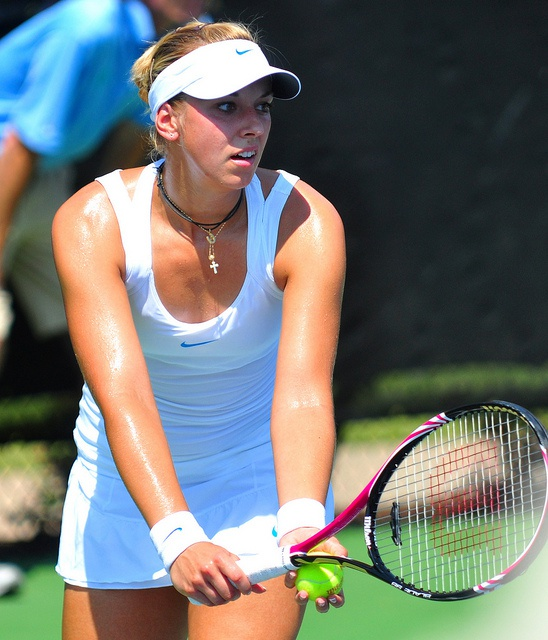Describe the objects in this image and their specific colors. I can see people in black, white, lightblue, salmon, and tan tones, people in black, teal, gray, and lightblue tones, tennis racket in black, darkgray, ivory, and lightgreen tones, and sports ball in black, lime, green, and yellow tones in this image. 